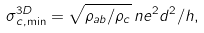<formula> <loc_0><loc_0><loc_500><loc_500>\sigma _ { c , \min } ^ { 3 D } = \sqrt { \rho _ { a b } / \rho _ { c } } \, n e ^ { 2 } d ^ { 2 } / h ,</formula> 